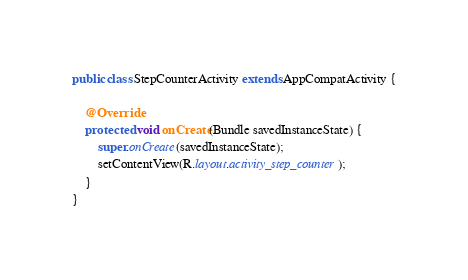Convert code to text. <code><loc_0><loc_0><loc_500><loc_500><_Java_>
public class StepCounterActivity extends AppCompatActivity {

    @Override
    protected void onCreate(Bundle savedInstanceState) {
        super.onCreate(savedInstanceState);
        setContentView(R.layout.activity_step_counter);
    }
}
</code> 